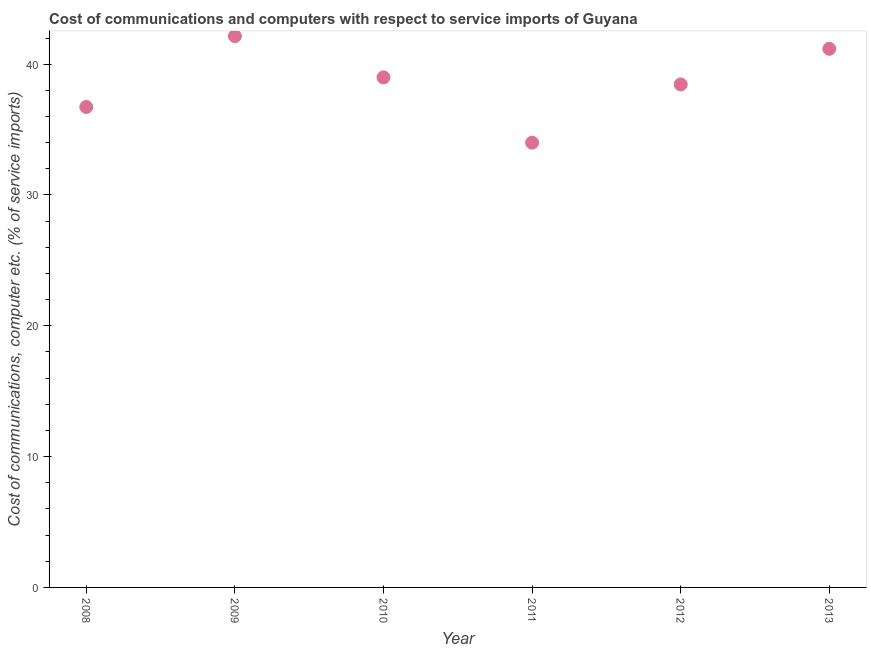What is the cost of communications and computer in 2011?
Your response must be concise. 34. Across all years, what is the maximum cost of communications and computer?
Your answer should be very brief. 42.14. Across all years, what is the minimum cost of communications and computer?
Your response must be concise. 34. In which year was the cost of communications and computer maximum?
Your answer should be very brief. 2009. What is the sum of the cost of communications and computer?
Ensure brevity in your answer.  231.48. What is the difference between the cost of communications and computer in 2008 and 2012?
Make the answer very short. -1.72. What is the average cost of communications and computer per year?
Your answer should be very brief. 38.58. What is the median cost of communications and computer?
Provide a succinct answer. 38.72. In how many years, is the cost of communications and computer greater than 16 %?
Your answer should be compact. 6. Do a majority of the years between 2011 and 2008 (inclusive) have cost of communications and computer greater than 8 %?
Keep it short and to the point. Yes. What is the ratio of the cost of communications and computer in 2012 to that in 2013?
Ensure brevity in your answer.  0.93. Is the difference between the cost of communications and computer in 2012 and 2013 greater than the difference between any two years?
Your answer should be very brief. No. What is the difference between the highest and the second highest cost of communications and computer?
Your answer should be very brief. 0.97. What is the difference between the highest and the lowest cost of communications and computer?
Provide a short and direct response. 8.14. Does the cost of communications and computer monotonically increase over the years?
Ensure brevity in your answer.  No. How many dotlines are there?
Provide a short and direct response. 1. What is the difference between two consecutive major ticks on the Y-axis?
Offer a very short reply. 10. Are the values on the major ticks of Y-axis written in scientific E-notation?
Your answer should be very brief. No. Does the graph contain any zero values?
Offer a very short reply. No. What is the title of the graph?
Offer a terse response. Cost of communications and computers with respect to service imports of Guyana. What is the label or title of the Y-axis?
Your response must be concise. Cost of communications, computer etc. (% of service imports). What is the Cost of communications, computer etc. (% of service imports) in 2008?
Your response must be concise. 36.73. What is the Cost of communications, computer etc. (% of service imports) in 2009?
Offer a terse response. 42.14. What is the Cost of communications, computer etc. (% of service imports) in 2010?
Give a very brief answer. 38.99. What is the Cost of communications, computer etc. (% of service imports) in 2011?
Provide a short and direct response. 34. What is the Cost of communications, computer etc. (% of service imports) in 2012?
Ensure brevity in your answer.  38.45. What is the Cost of communications, computer etc. (% of service imports) in 2013?
Offer a very short reply. 41.17. What is the difference between the Cost of communications, computer etc. (% of service imports) in 2008 and 2009?
Your answer should be compact. -5.41. What is the difference between the Cost of communications, computer etc. (% of service imports) in 2008 and 2010?
Give a very brief answer. -2.26. What is the difference between the Cost of communications, computer etc. (% of service imports) in 2008 and 2011?
Offer a terse response. 2.73. What is the difference between the Cost of communications, computer etc. (% of service imports) in 2008 and 2012?
Your answer should be compact. -1.72. What is the difference between the Cost of communications, computer etc. (% of service imports) in 2008 and 2013?
Keep it short and to the point. -4.45. What is the difference between the Cost of communications, computer etc. (% of service imports) in 2009 and 2010?
Offer a very short reply. 3.15. What is the difference between the Cost of communications, computer etc. (% of service imports) in 2009 and 2011?
Your response must be concise. 8.14. What is the difference between the Cost of communications, computer etc. (% of service imports) in 2009 and 2012?
Give a very brief answer. 3.69. What is the difference between the Cost of communications, computer etc. (% of service imports) in 2009 and 2013?
Offer a terse response. 0.97. What is the difference between the Cost of communications, computer etc. (% of service imports) in 2010 and 2011?
Provide a succinct answer. 4.99. What is the difference between the Cost of communications, computer etc. (% of service imports) in 2010 and 2012?
Ensure brevity in your answer.  0.54. What is the difference between the Cost of communications, computer etc. (% of service imports) in 2010 and 2013?
Make the answer very short. -2.19. What is the difference between the Cost of communications, computer etc. (% of service imports) in 2011 and 2012?
Provide a succinct answer. -4.45. What is the difference between the Cost of communications, computer etc. (% of service imports) in 2011 and 2013?
Your response must be concise. -7.17. What is the difference between the Cost of communications, computer etc. (% of service imports) in 2012 and 2013?
Offer a very short reply. -2.72. What is the ratio of the Cost of communications, computer etc. (% of service imports) in 2008 to that in 2009?
Provide a succinct answer. 0.87. What is the ratio of the Cost of communications, computer etc. (% of service imports) in 2008 to that in 2010?
Offer a terse response. 0.94. What is the ratio of the Cost of communications, computer etc. (% of service imports) in 2008 to that in 2011?
Offer a terse response. 1.08. What is the ratio of the Cost of communications, computer etc. (% of service imports) in 2008 to that in 2012?
Make the answer very short. 0.95. What is the ratio of the Cost of communications, computer etc. (% of service imports) in 2008 to that in 2013?
Offer a terse response. 0.89. What is the ratio of the Cost of communications, computer etc. (% of service imports) in 2009 to that in 2010?
Give a very brief answer. 1.08. What is the ratio of the Cost of communications, computer etc. (% of service imports) in 2009 to that in 2011?
Your response must be concise. 1.24. What is the ratio of the Cost of communications, computer etc. (% of service imports) in 2009 to that in 2012?
Your response must be concise. 1.1. What is the ratio of the Cost of communications, computer etc. (% of service imports) in 2010 to that in 2011?
Offer a very short reply. 1.15. What is the ratio of the Cost of communications, computer etc. (% of service imports) in 2010 to that in 2013?
Your response must be concise. 0.95. What is the ratio of the Cost of communications, computer etc. (% of service imports) in 2011 to that in 2012?
Make the answer very short. 0.88. What is the ratio of the Cost of communications, computer etc. (% of service imports) in 2011 to that in 2013?
Your response must be concise. 0.83. What is the ratio of the Cost of communications, computer etc. (% of service imports) in 2012 to that in 2013?
Make the answer very short. 0.93. 